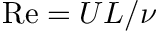<formula> <loc_0><loc_0><loc_500><loc_500>R e = U L / \nu</formula> 